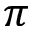<formula> <loc_0><loc_0><loc_500><loc_500>\pi</formula> 